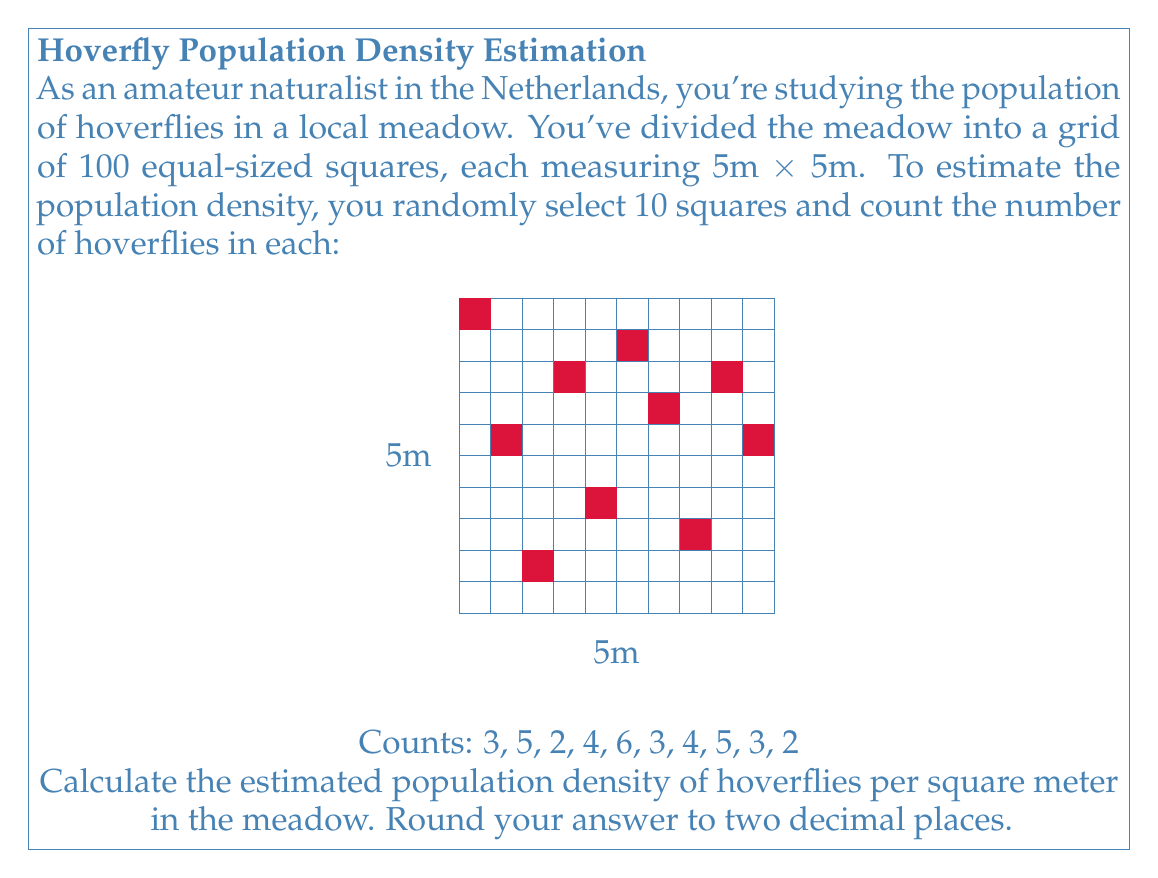Can you answer this question? Let's approach this step-by-step:

1) First, we need to calculate the mean number of hoverflies per sampled square:

   $\bar{x} = \frac{3 + 5 + 2 + 4 + 6 + 3 + 4 + 5 + 3 + 2}{10} = \frac{37}{10} = 3.7$

2) This mean represents the average number of hoverflies in a 5m x 5m square.

3) To find the density per square meter, we need to divide this by the area of each square:

   Area of each square = 5m × 5m = 25 m²

4) Density per square meter = $\frac{3.7}{25} = 0.148$ hoverflies/m²

5) Rounding to two decimal places: 0.15 hoverflies/m²

To express this as an equation:

$$\text{Density} = \frac{\frac{1}{n}\sum_{i=1}^{n} x_i}{A}$$

Where:
- $n$ is the number of sampled squares (10)
- $x_i$ are the individual counts
- $A$ is the area of each square in m² (25)

Substituting our values:

$$\text{Density} = \frac{\frac{1}{10}(3 + 5 + 2 + 4 + 6 + 3 + 4 + 5 + 3 + 2)}{25} \approx 0.15 \text{ hoverflies/m²}$$
Answer: 0.15 hoverflies/m² 